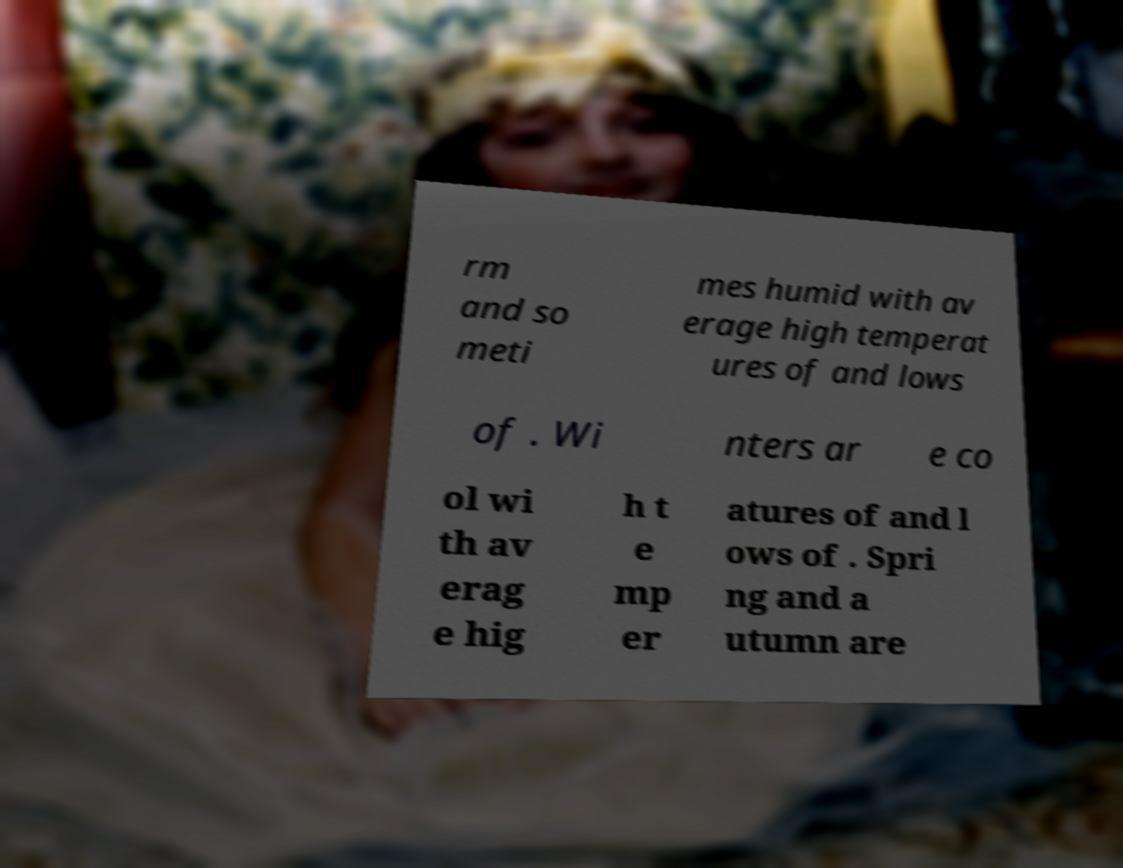Could you extract and type out the text from this image? rm and so meti mes humid with av erage high temperat ures of and lows of . Wi nters ar e co ol wi th av erag e hig h t e mp er atures of and l ows of . Spri ng and a utumn are 